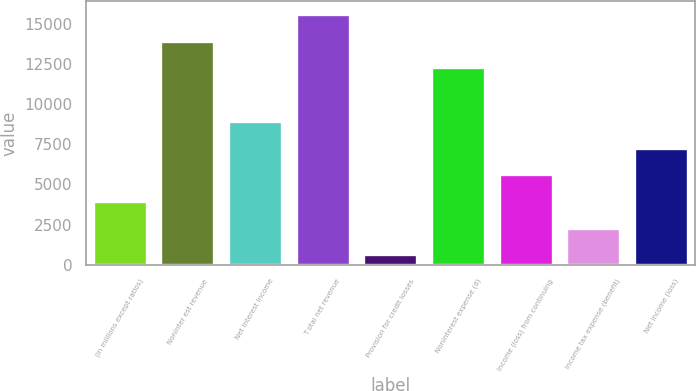Convert chart to OTSL. <chart><loc_0><loc_0><loc_500><loc_500><bar_chart><fcel>(in millions except ratios)<fcel>Noninter est revenue<fcel>Net interest income<fcel>T otal net revenue<fcel>Provision for credit losses<fcel>Noninterest expense (d)<fcel>Income (loss) from continuing<fcel>Income tax expense (benefit)<fcel>Net income (loss)<nl><fcel>3970<fcel>13960<fcel>8965<fcel>15625<fcel>640<fcel>12295<fcel>5635<fcel>2305<fcel>7300<nl></chart> 